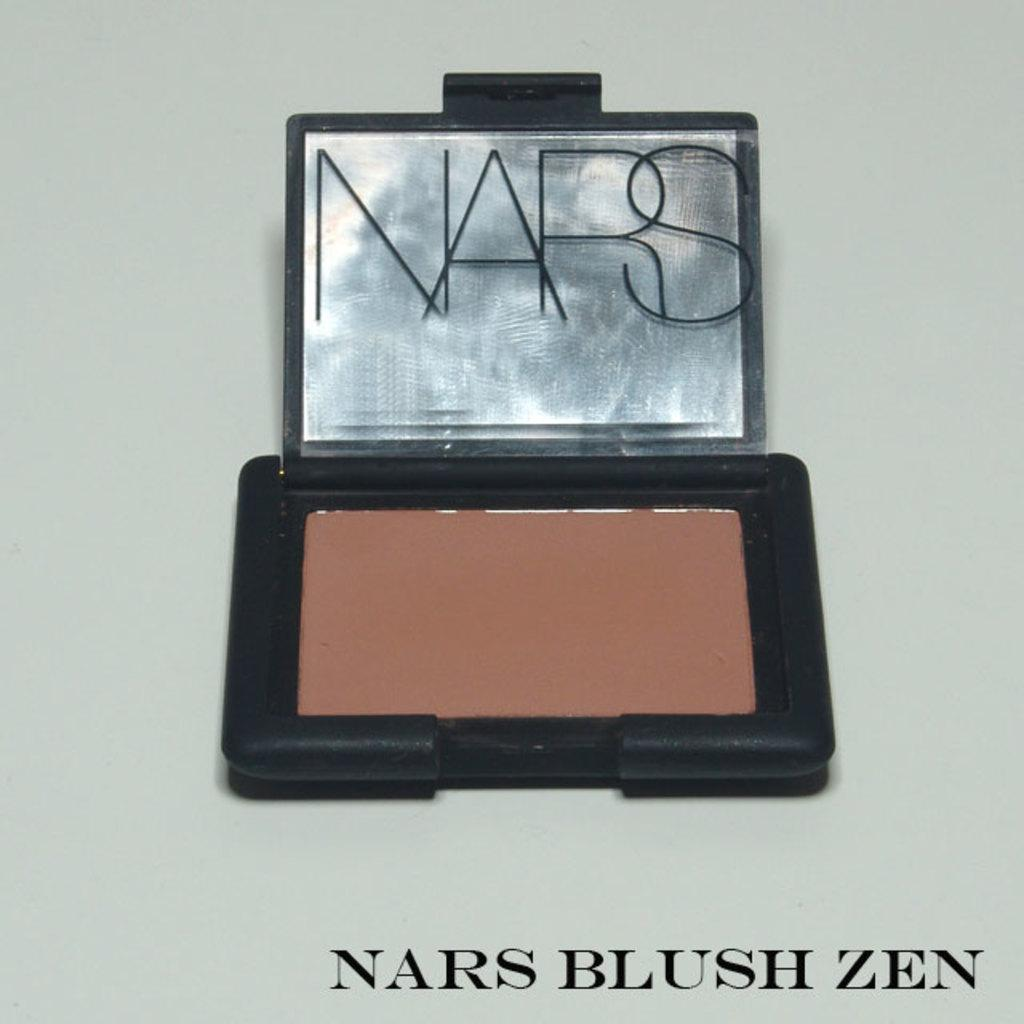<image>
Relay a brief, clear account of the picture shown. The brand of makeup shown is Nars Blush Zen 